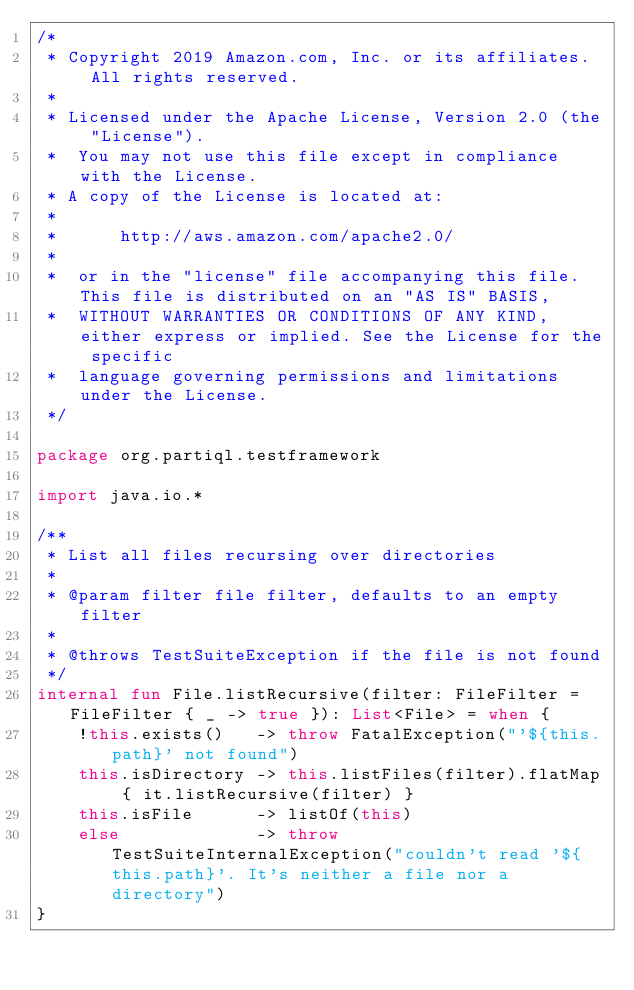<code> <loc_0><loc_0><loc_500><loc_500><_Kotlin_>/*
 * Copyright 2019 Amazon.com, Inc. or its affiliates.  All rights reserved.
 *
 * Licensed under the Apache License, Version 2.0 (the "License").
 *  You may not use this file except in compliance with the License.
 * A copy of the License is located at:
 *
 *      http://aws.amazon.com/apache2.0/
 *
 *  or in the "license" file accompanying this file. This file is distributed on an "AS IS" BASIS,
 *  WITHOUT WARRANTIES OR CONDITIONS OF ANY KIND, either express or implied. See the License for the specific
 *  language governing permissions and limitations under the License.
 */

package org.partiql.testframework

import java.io.*

/**
 * List all files recursing over directories
 *
 * @param filter file filter, defaults to an empty filter
 *
 * @throws TestSuiteException if the file is not found
 */
internal fun File.listRecursive(filter: FileFilter = FileFilter { _ -> true }): List<File> = when {
    !this.exists()   -> throw FatalException("'${this.path}' not found")
    this.isDirectory -> this.listFiles(filter).flatMap { it.listRecursive(filter) }
    this.isFile      -> listOf(this)
    else             -> throw TestSuiteInternalException("couldn't read '${this.path}'. It's neither a file nor a directory")
}
</code> 